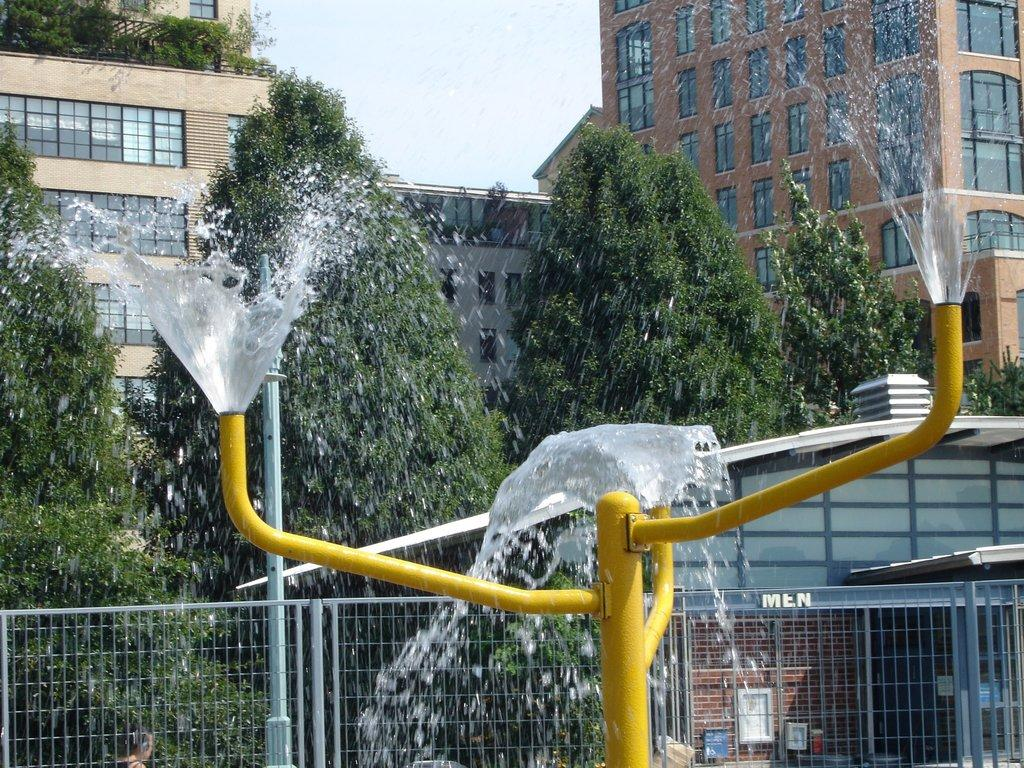What is coming out of the rods in the image? Water is coming from the rods in the image. What can be seen in the background of the image? There are buildings with windows and trees in the background of the image. How many basketballs can be seen in the image? There are no basketballs present in the image. 